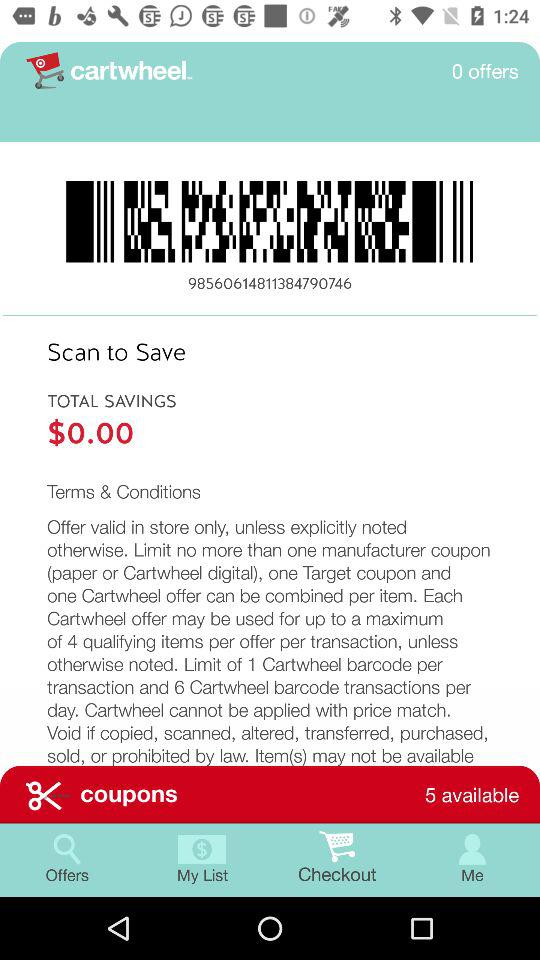Which option is selected? The selected option is "Checkout". 